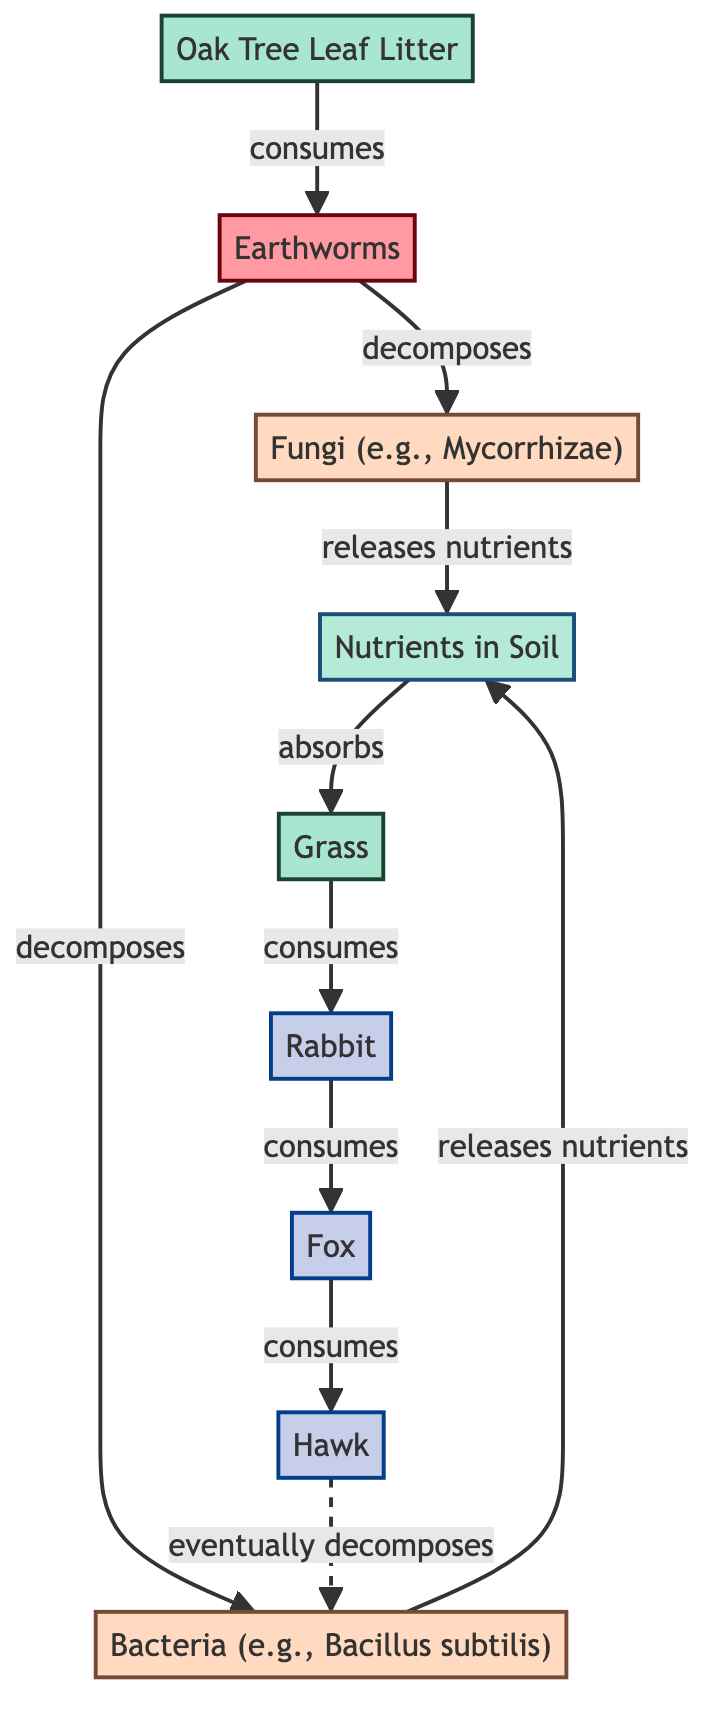What is the primary decomposer in the diagram? The primary decomposer shown in the diagram is the Earthworm, which directly consumes the Oak Tree Leaf Litter.
Answer: Earthworm How many secondary decomposers are present? The diagram shows two secondary decomposers: Fungi and Bacteria.
Answer: 2 What do fungi release into the soil? According to the diagram, fungi release nutrients into the soil as part of the decomposition process.
Answer: Nutrients Which producer absorbs nutrients from the soil? The Grass is identified as the producer that absorbs nutrients from the soil, as indicated in the flow of the diagram.
Answer: Grass Which consumer eats the Rabbit? The Fox is the consumer that directly consumes the Rabbit as per the connections in the diagram.
Answer: Fox What relationship do earthworms have with oak tree leaf litter? Earthworms decompose the Oak Tree Leaf Litter, transforming it into nutrients released into the soil.
Answer: Decomposes What ultimately happens to the hawk in the food chain? The diagram indicates that the hawk eventually decomposes through a process represented by a dash line that points towards bacteria, illustrating ecological recycling.
Answer: Decomposes How many nodes are there in total? The diagram consists of a total of nine nodes, which includes producers, decomposers, and consumers.
Answer: 9 Which node is connected to the nutrient cycle? Both Fungi and Bacteria release nutrients into the Nutrients in Soil node, which is a part of the nutrient cycle.
Answer: Nutrients in Soil 